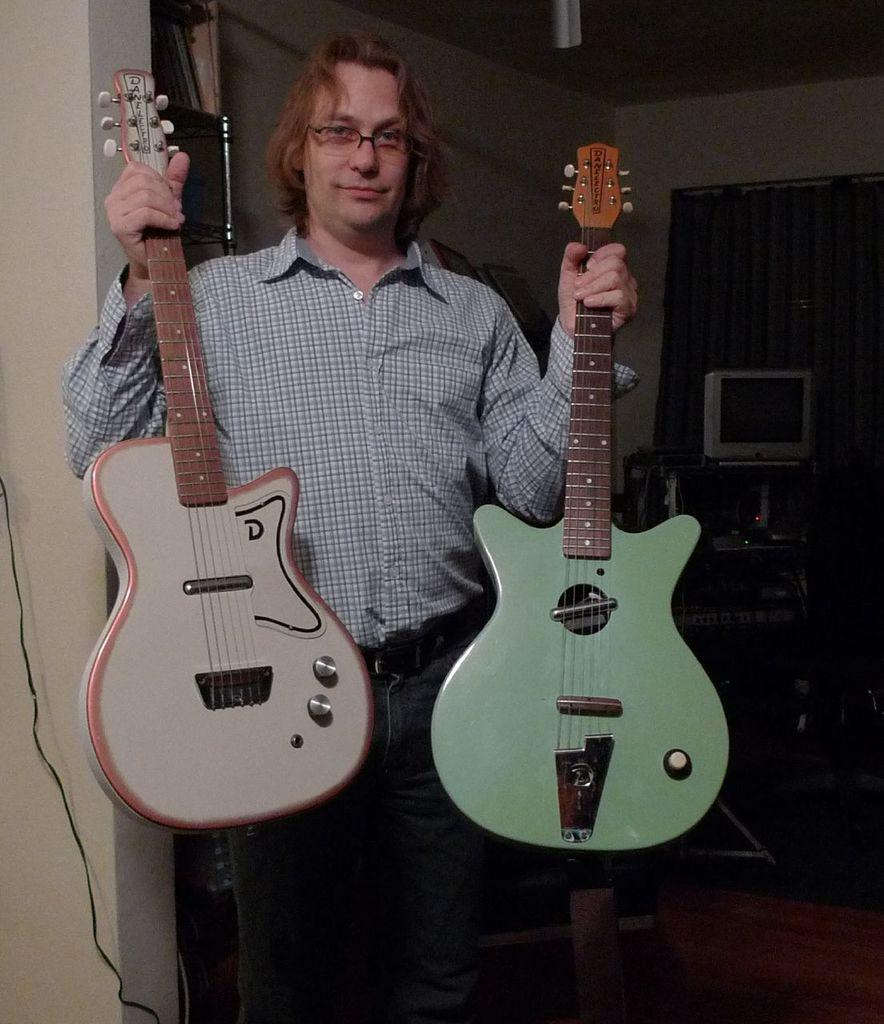What is the main subject of the image? The main subject of the image is a man. What is the man holding in the image? The man is holding guitars in the image. Can you describe the man's appearance? The man is wearing spectacles in the image. What can be seen in the background of the image? There is a television on a table and curtains in the background of the image. What type of volleyball is the man playing in the image? There is no volleyball present in the image; the man is holding guitars. What are the man's hobbies, as suggested by the image? The image does not provide information about the man's hobbies, only that he is holding guitars. Can you locate the key in the image? There is no key present in the image. 